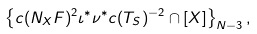<formula> <loc_0><loc_0><loc_500><loc_500>\left \{ c ( N _ { X } F ) ^ { 2 } \iota ^ { \ast } \nu ^ { \ast } c ( T _ { S } ) ^ { - 2 } \cap [ X ] \right \} _ { N - 3 } ,</formula> 